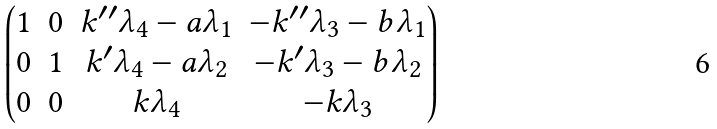Convert formula to latex. <formula><loc_0><loc_0><loc_500><loc_500>\begin{pmatrix} 1 & 0 & k ^ { \prime \prime } \lambda _ { 4 } - a \lambda _ { 1 } & - k ^ { \prime \prime } \lambda _ { 3 } - b \lambda _ { 1 } \\ 0 & 1 & k ^ { \prime } \lambda _ { 4 } - a \lambda _ { 2 } & - k ^ { \prime } \lambda _ { 3 } - b \lambda _ { 2 } \\ 0 & 0 & k \lambda _ { 4 } & - k \lambda _ { 3 } \\ \end{pmatrix}</formula> 